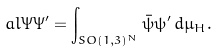<formula> <loc_0><loc_0><loc_500><loc_500>a l { \Psi } { \Psi ^ { \prime } } = \int _ { S O ( 1 , 3 ) ^ { N } } \bar { \psi } \psi ^ { \prime } \, d \mu _ { H } .</formula> 